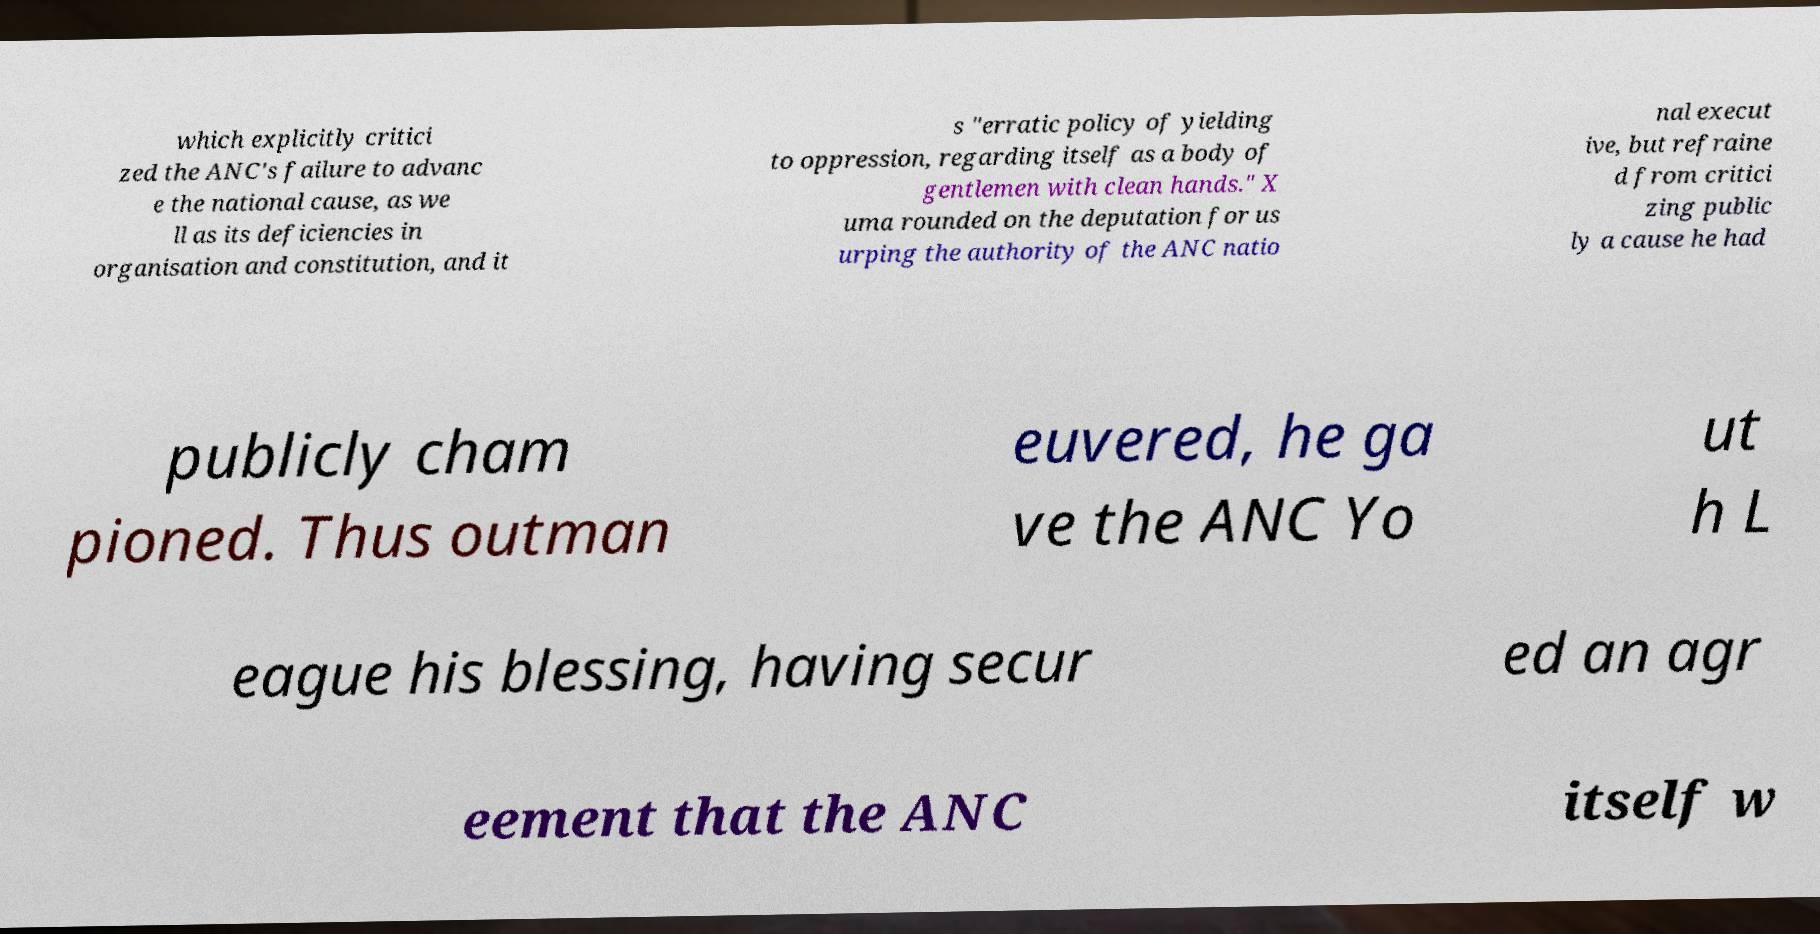What messages or text are displayed in this image? I need them in a readable, typed format. which explicitly critici zed the ANC's failure to advanc e the national cause, as we ll as its deficiencies in organisation and constitution, and it s "erratic policy of yielding to oppression, regarding itself as a body of gentlemen with clean hands." X uma rounded on the deputation for us urping the authority of the ANC natio nal execut ive, but refraine d from critici zing public ly a cause he had publicly cham pioned. Thus outman euvered, he ga ve the ANC Yo ut h L eague his blessing, having secur ed an agr eement that the ANC itself w 